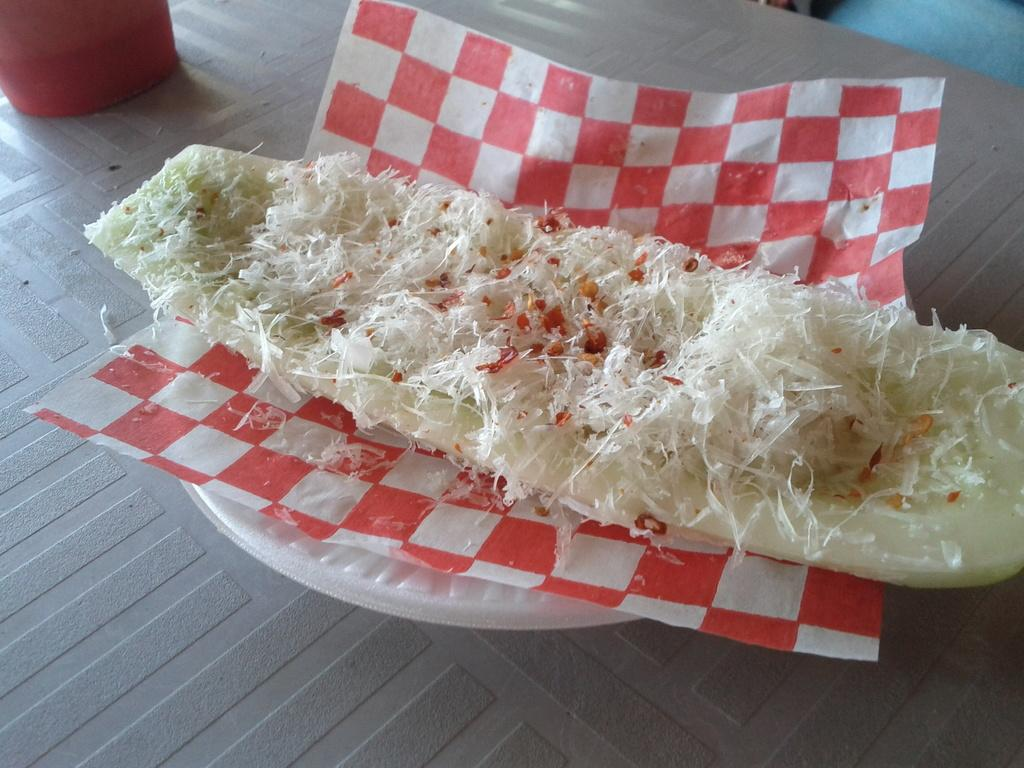What is the food item placed on in the image? The food item is on a tissue in the image. Is the food item placed on any other surface besides the tissue? Yes, the food item is also on a bowl. What other object can be seen in the image? There is a glass in the image. Where is the glass located in the image? The glass is at the top side of the image. What does the son think about the taste of the food item in the image? There is no mention of a son or any taste in the image, so it cannot be determined from the image. 